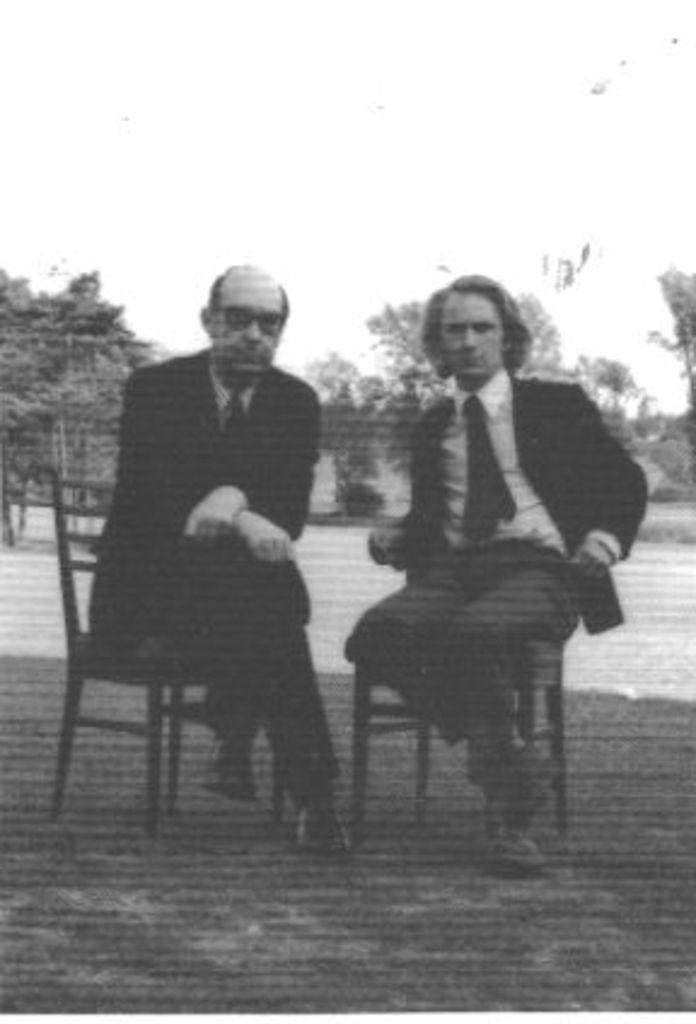How many people are in the image? There are two people in the image. What are the people doing in the image? The people are sitting on chairs. What are the people wearing in the image? The people are wearing black jackets. What can be seen in the background of the image? There are trees visible behind the people. What is the color of the background in the image? The background of the image is white. What type of angle is the thing in the image leaning at? There is no "thing" in the image that is leaning, and therefore no angle can be determined. 